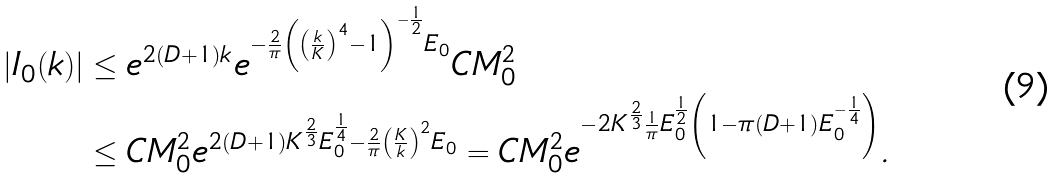<formula> <loc_0><loc_0><loc_500><loc_500>| I _ { 0 } ( k ) | & \leq e ^ { 2 ( D + 1 ) k } e ^ { - \frac { 2 } { \pi } \left ( \left ( \frac { k } { K } \right ) ^ { 4 } - 1 \right ) ^ { - \frac { 1 } { 2 } } E _ { 0 } } C M _ { 0 } ^ { 2 } \\ & \leq C M _ { 0 } ^ { 2 } e ^ { 2 ( D + 1 ) K ^ { \frac { 2 } { 3 } } E _ { 0 } ^ { \frac { 1 } { 4 } } - \frac { 2 } { \pi } \left ( \frac { K } { k } \right ) ^ { 2 } E _ { 0 } } = C M _ { 0 } ^ { 2 } e ^ { - 2 K ^ { \frac { 2 } { 3 } } \frac { 1 } { \pi } E _ { 0 } ^ { \frac { 1 } { 2 } } \left ( 1 - \pi ( D + 1 ) E _ { 0 } ^ { - \frac { 1 } { 4 } } \right ) } .</formula> 